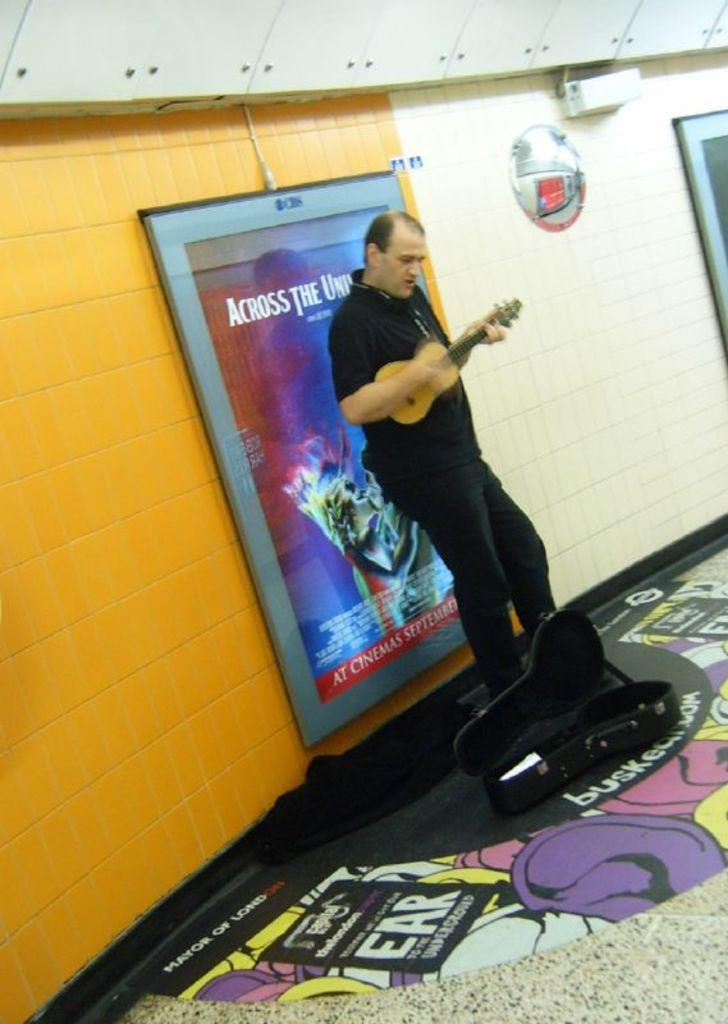Where was the image taken? The image was taken inside a room. Who is present in the image? There is a man in the image. What is the man doing in the image? The man is playing the guitar. What can be seen in the background of the image? There are hoardings and tiles in the background of the image. What objects are at the bottom of the image? There is a suitcase and a mat at the bottom of the image. What type of spot can be seen on the guitar in the image? There is no spot visible on the guitar in the image. What kind of loaf is the man holding while playing the guitar? The man is not holding a loaf in the image; he is holding a guitar. 